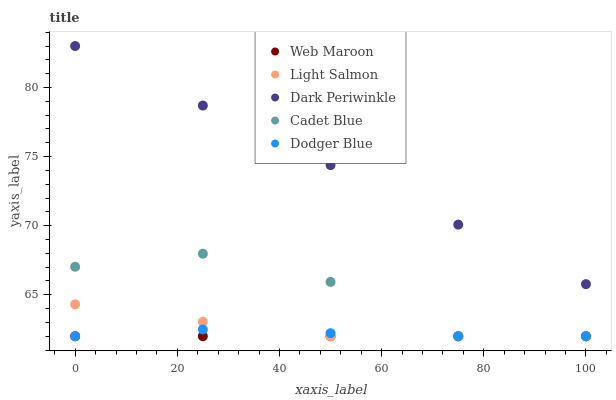Does Web Maroon have the minimum area under the curve?
Answer yes or no. Yes. Does Dark Periwinkle have the maximum area under the curve?
Answer yes or no. Yes. Does Light Salmon have the minimum area under the curve?
Answer yes or no. No. Does Light Salmon have the maximum area under the curve?
Answer yes or no. No. Is Web Maroon the smoothest?
Answer yes or no. Yes. Is Cadet Blue the roughest?
Answer yes or no. Yes. Is Light Salmon the smoothest?
Answer yes or no. No. Is Light Salmon the roughest?
Answer yes or no. No. Does Dodger Blue have the lowest value?
Answer yes or no. Yes. Does Dark Periwinkle have the lowest value?
Answer yes or no. No. Does Dark Periwinkle have the highest value?
Answer yes or no. Yes. Does Light Salmon have the highest value?
Answer yes or no. No. Is Dodger Blue less than Dark Periwinkle?
Answer yes or no. Yes. Is Dark Periwinkle greater than Light Salmon?
Answer yes or no. Yes. Does Cadet Blue intersect Light Salmon?
Answer yes or no. Yes. Is Cadet Blue less than Light Salmon?
Answer yes or no. No. Is Cadet Blue greater than Light Salmon?
Answer yes or no. No. Does Dodger Blue intersect Dark Periwinkle?
Answer yes or no. No. 